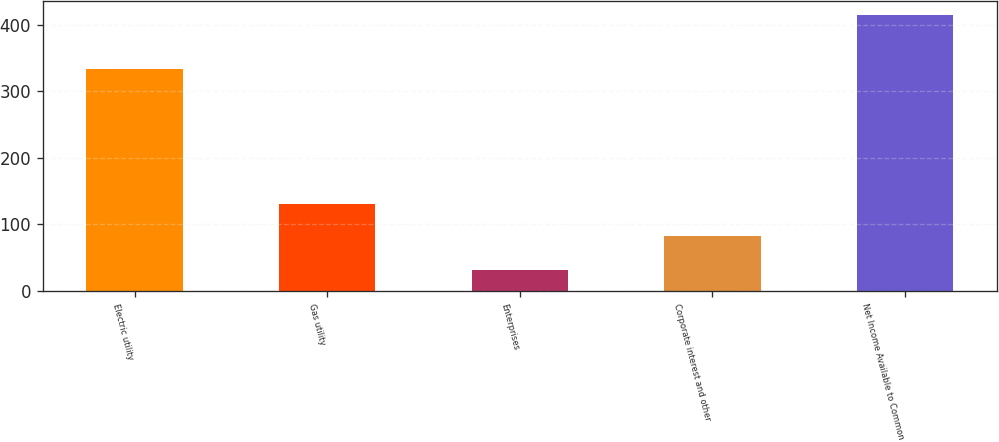<chart> <loc_0><loc_0><loc_500><loc_500><bar_chart><fcel>Electric utility<fcel>Gas utility<fcel>Enterprises<fcel>Corporate interest and other<fcel>Net Income Available to Common<nl><fcel>333<fcel>130<fcel>32<fcel>82<fcel>415<nl></chart> 